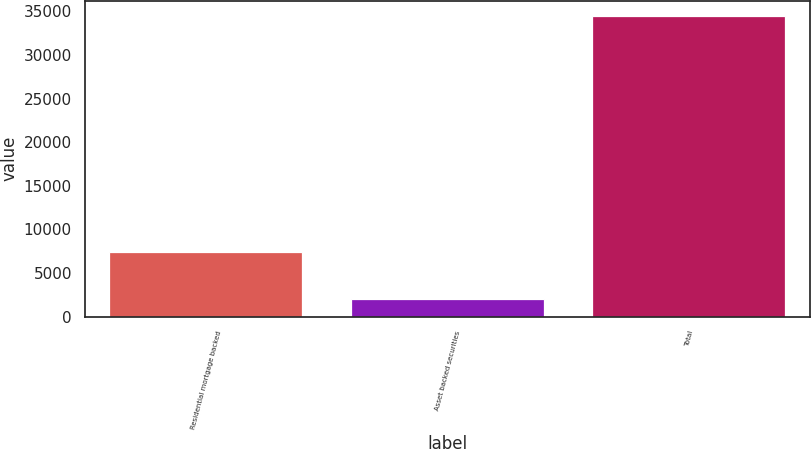Convert chart to OTSL. <chart><loc_0><loc_0><loc_500><loc_500><bar_chart><fcel>Residential mortgage backed<fcel>Asset backed securities<fcel>Total<nl><fcel>7396<fcel>1985<fcel>34505<nl></chart> 